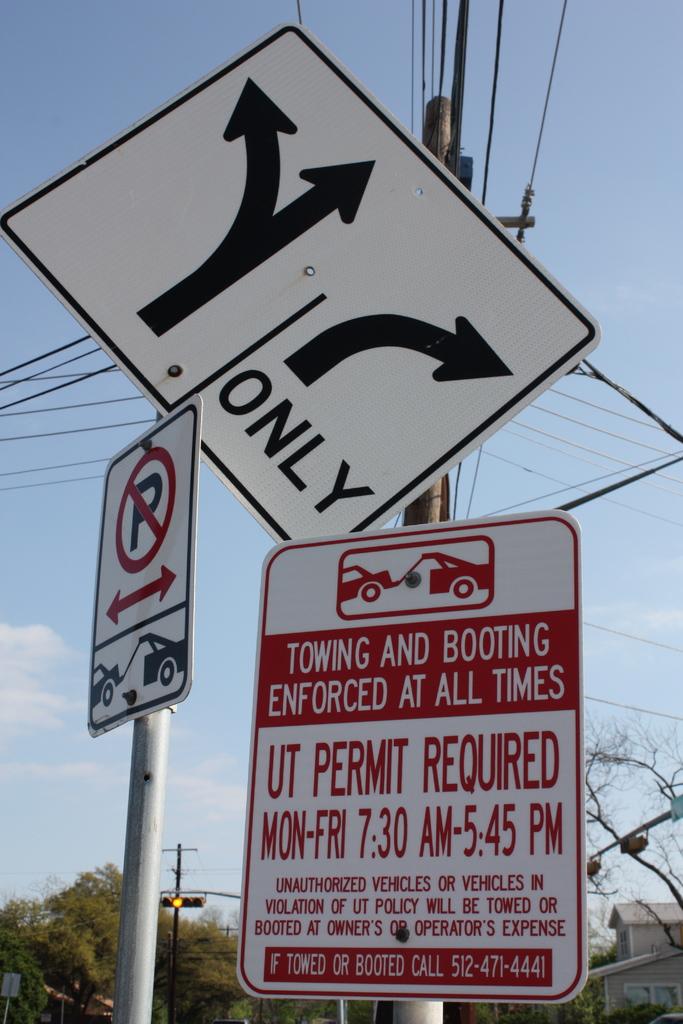What time is the ut permit required?
Provide a succinct answer. 7:30 am - 5:45 pm. Is towing and booting enforced at all times?
Give a very brief answer. Yes. 